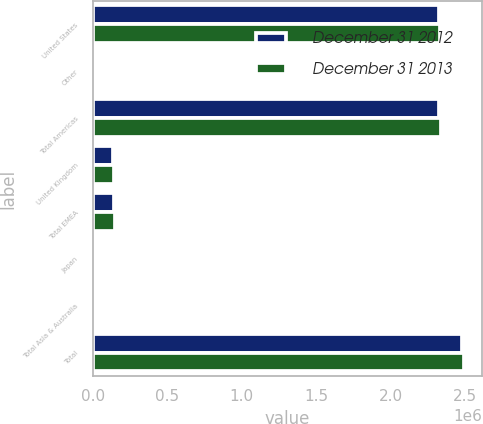<chart> <loc_0><loc_0><loc_500><loc_500><stacked_bar_chart><ecel><fcel>United States<fcel>Other<fcel>Total Americas<fcel>United Kingdom<fcel>Total EMEA<fcel>Japan<fcel>Total Asia & Australia<fcel>Total<nl><fcel>December 31 2012<fcel>2.32378e+06<fcel>4082<fcel>2.32786e+06<fcel>133411<fcel>145282<fcel>1543<fcel>6971<fcel>2.48012e+06<nl><fcel>December 31 2013<fcel>2.33488e+06<fcel>4608<fcel>2.33948e+06<fcel>139714<fcel>148463<fcel>297<fcel>3955<fcel>2.4919e+06<nl></chart> 